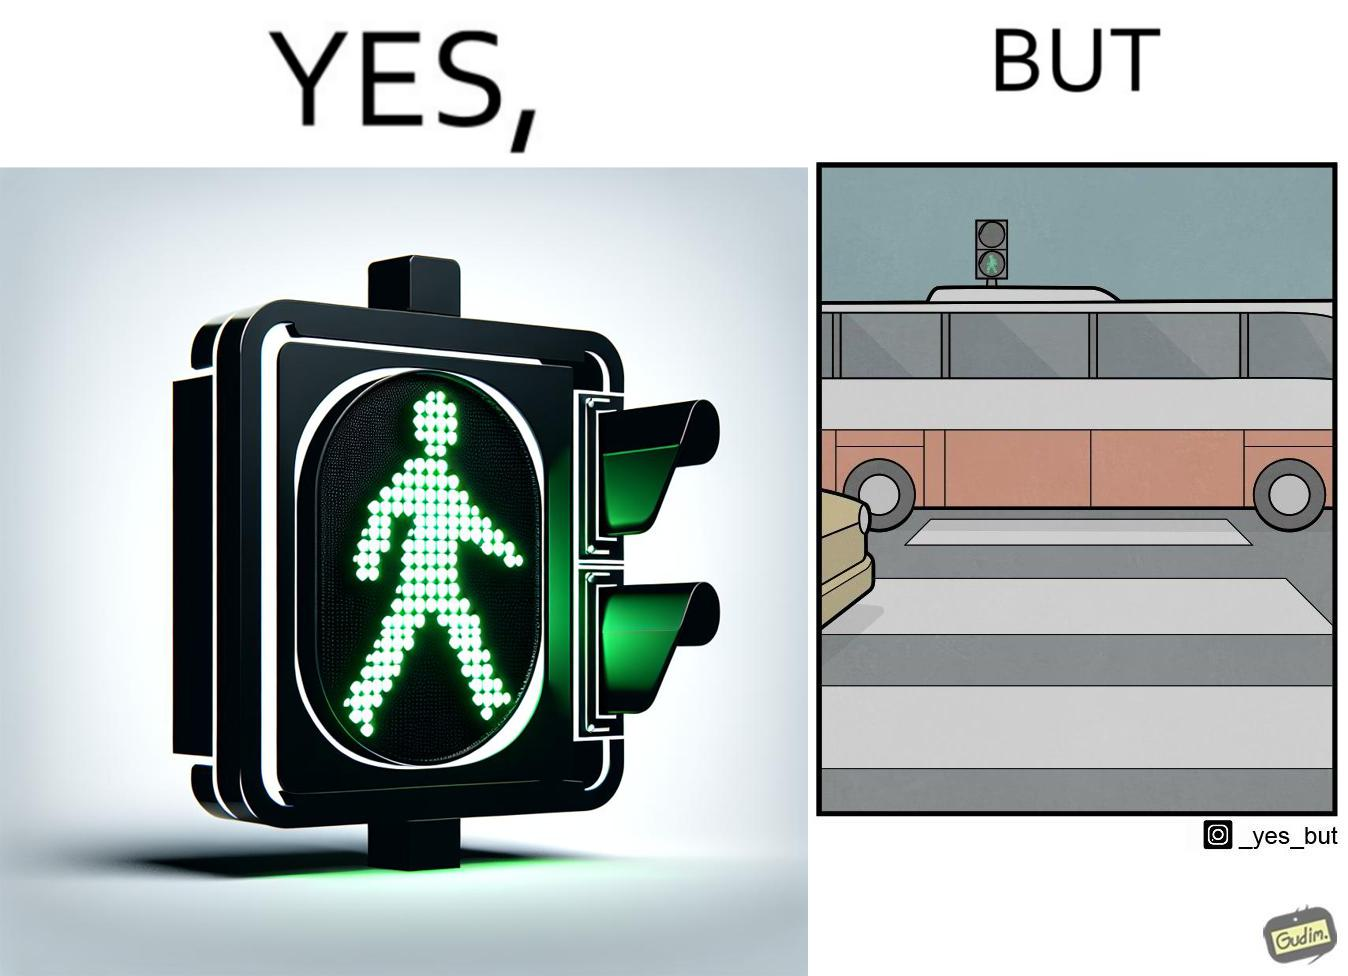Does this image contain satire or humor? Yes, this image is satirical. 